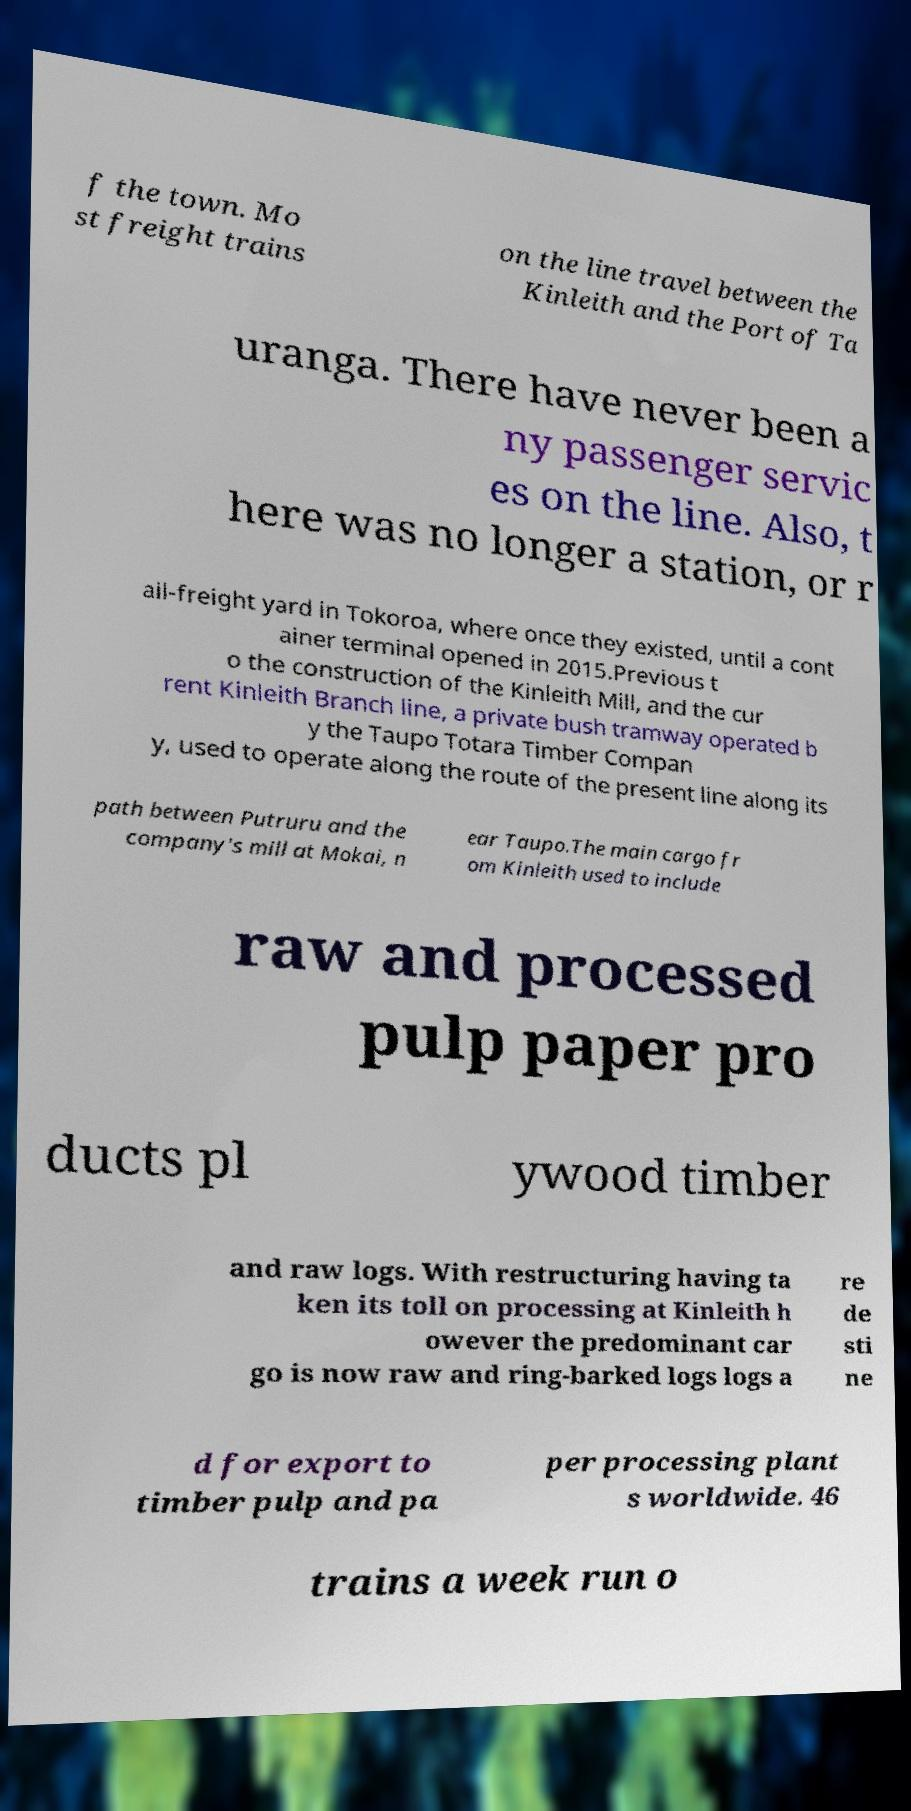Please identify and transcribe the text found in this image. f the town. Mo st freight trains on the line travel between the Kinleith and the Port of Ta uranga. There have never been a ny passenger servic es on the line. Also, t here was no longer a station, or r ail-freight yard in Tokoroa, where once they existed, until a cont ainer terminal opened in 2015.Previous t o the construction of the Kinleith Mill, and the cur rent Kinleith Branch line, a private bush tramway operated b y the Taupo Totara Timber Compan y, used to operate along the route of the present line along its path between Putruru and the company's mill at Mokai, n ear Taupo.The main cargo fr om Kinleith used to include raw and processed pulp paper pro ducts pl ywood timber and raw logs. With restructuring having ta ken its toll on processing at Kinleith h owever the predominant car go is now raw and ring-barked logs logs a re de sti ne d for export to timber pulp and pa per processing plant s worldwide. 46 trains a week run o 